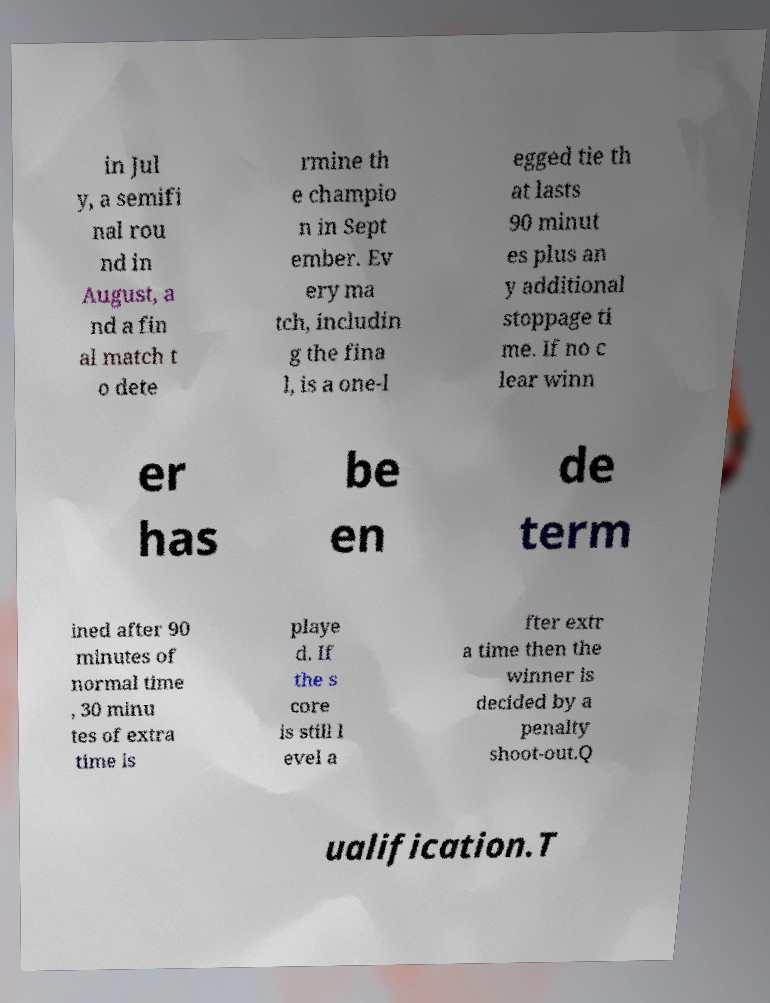Could you assist in decoding the text presented in this image and type it out clearly? in Jul y, a semifi nal rou nd in August, a nd a fin al match t o dete rmine th e champio n in Sept ember. Ev ery ma tch, includin g the fina l, is a one-l egged tie th at lasts 90 minut es plus an y additional stoppage ti me. If no c lear winn er has be en de term ined after 90 minutes of normal time , 30 minu tes of extra time is playe d. If the s core is still l evel a fter extr a time then the winner is decided by a penalty shoot-out.Q ualification.T 